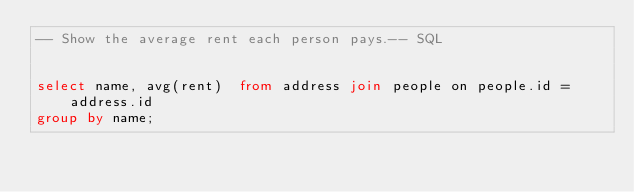Convert code to text. <code><loc_0><loc_0><loc_500><loc_500><_SQL_>-- Show the average rent each person pays.-- SQL


select name, avg(rent)  from address join people on people.id = address.id
group by name;</code> 